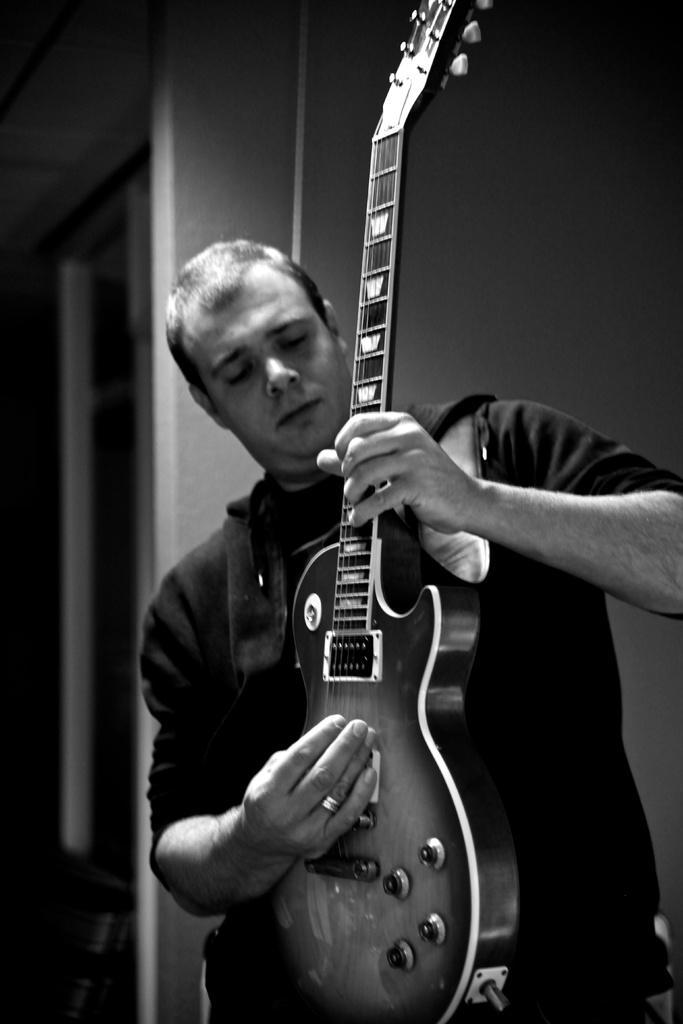How would you summarize this image in a sentence or two? The image is in black and white color. A person holding a guitar and playing it. He is wearing a black T shirt. In the background there is a window. 